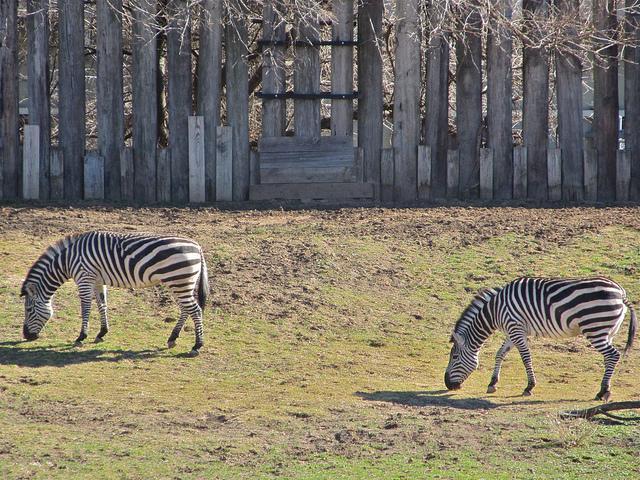How many zebras are in the photo?
Give a very brief answer. 2. 